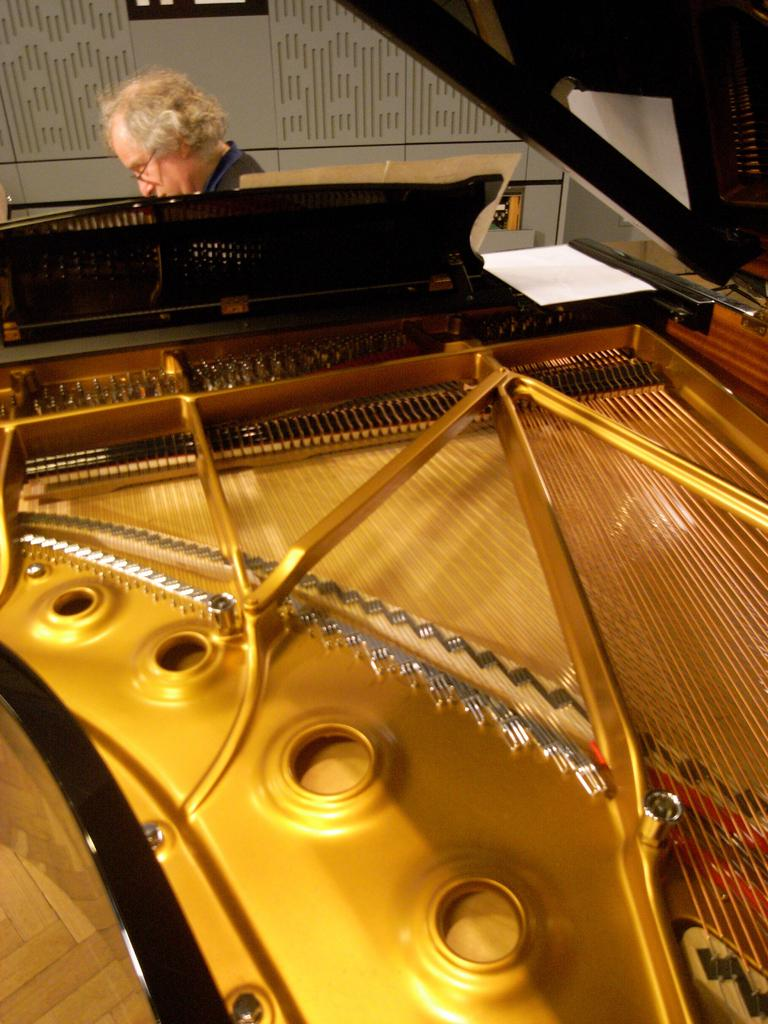What is the man in the image doing? There is a man seated in the image. What object related to documentation or reading can be seen in the image? There is a paper in the image. What type of object is present in the image that is typically used for creating music? There is an instrument in the image. What type of ship can be seen sailing in the background of the image? There is no ship present in the image; it only features a man seated, a paper, and an instrument. 